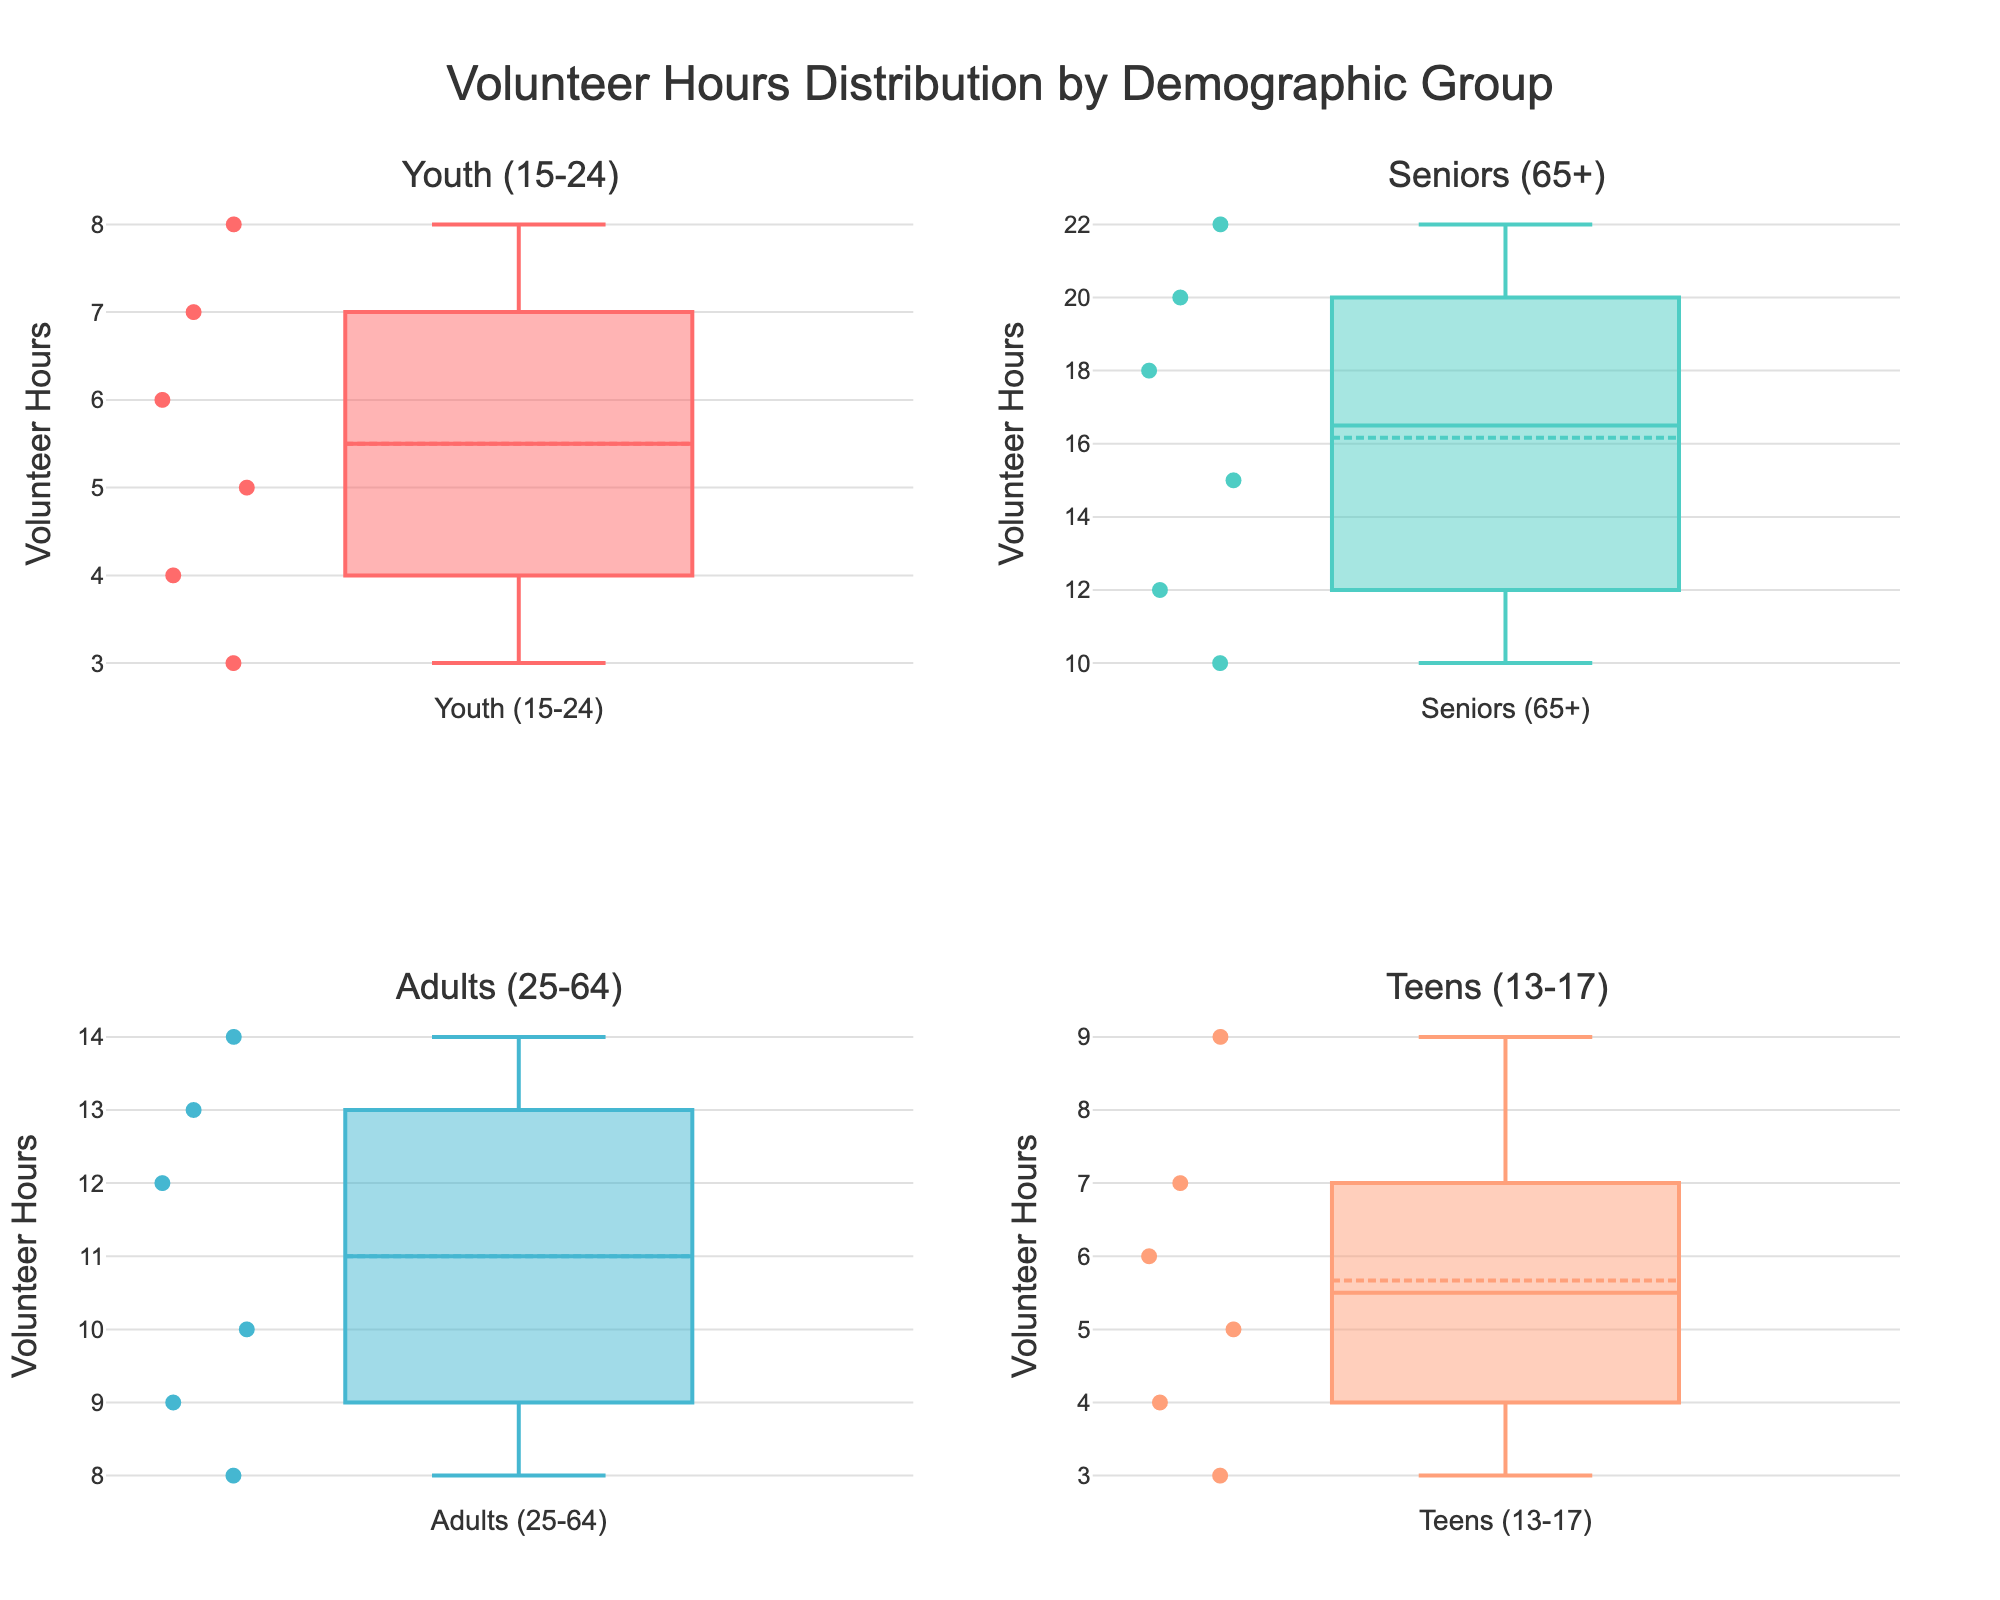What is the title of the figure? The title of the figure is written at the top and provides an overview of the visualized data. It helps users to understand what the figure is about quickly.
Answer: Volunteer Hours Distribution by Demographic Group Which demographic group has the highest median volunteer hours? By looking at the middle line of each boxplot, which represents the median, we can compare the median values for each demographic group.
Answer: Seniors (65+) How many unique demographic groups are represented in the figure? There are multiple subplots, each representing a different demographic group. By counting the subplot titles, we can determine the number of unique groups.
Answer: Four What is the range of volunteer hours contributed by the 'Youth (15-24)' group? The range is determined by the difference between the maximum and minimum values in the boxplot for 'Youth (15-24)'. The whiskers of the boxplot help identify these values.
Answer: 3-8 Which entity in the 'Seniors (65+)' group contributes the highest number of volunteer hours? By identifying the highest data point within the 'Seniors (65+)' boxplot and checking the associated entity name, we can determine the entity with the highest contribution.
Answer: Senior Companion Program What is the average value of volunteer hours contributed by the 'Teens (13-17)' group? To find the average, add up all volunteer hours contributed by entities in the 'Teens (13-17)' group and divide by the number of entities. Sum of hours = 4+5+7+6+9+3 = 34; Number of entities = 6; Average = 34/6
Answer: 5.67 Compare the median volunteer hours between 'Adults (25-64)' and 'Youth (15-24)'. Which group has a higher median? By looking at the middle lines of the boxplots for 'Adults (25-64)' and 'Youth (15-24)', we can compare their medians. 'Adults (25-64)': median = 11; 'Youth (15-24)': median = 5.5
Answer: Adults (25-64) Which group has the broadest range of volunteer hours? The range is determined by subtracting the minimum value from the maximum value in each group’s boxplot. The group with the largest difference has the broadest range.
Answer: Seniors (65+) How do volunteer hours of 'Teens (13-17)' compare to 'Adults (25-64)' in terms of variability? Variability can be seen by the spread of data points (whiskers and box size). By comparing the boxplots for 'Teens (13-17)' and 'Adults (25-64)', we see which group has more spread-out data points.
Answer: Teens (13-17) have less variability than Adults (25-64) What is the maximum number of volunteer hours recorded for 'Adults (25-64)'? The maximum value can be identified by the top whisker of the 'Adults (25-64)' boxplot, which represents the highest data point.
Answer: 14 